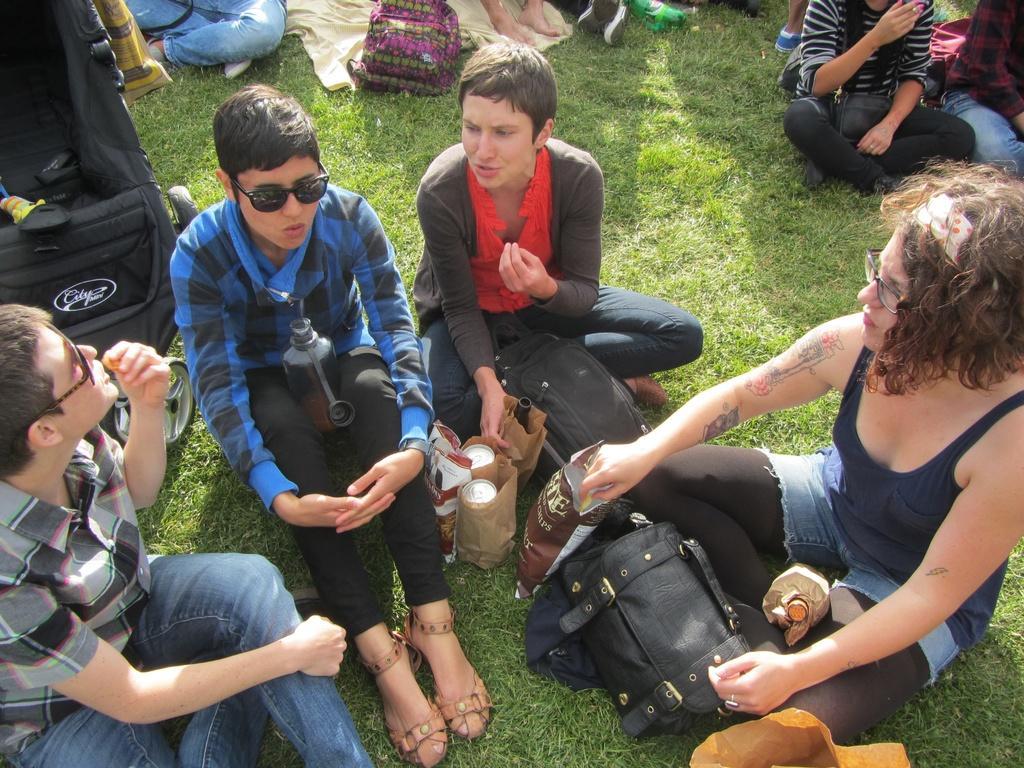Can you describe this image briefly? In this picture there are people sitting on the grass. In the picture there are tins, packs, bags and grass. 